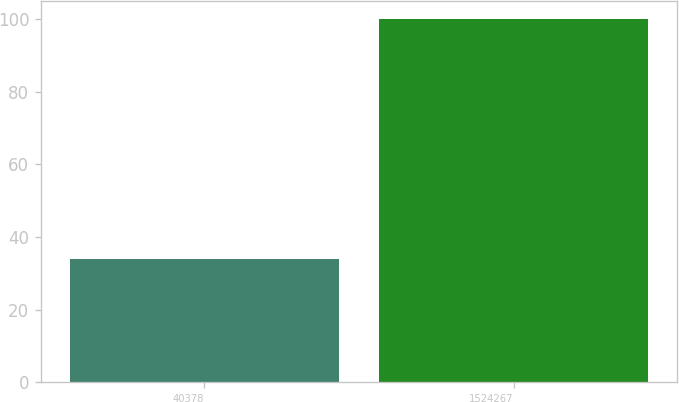Convert chart to OTSL. <chart><loc_0><loc_0><loc_500><loc_500><bar_chart><fcel>40378<fcel>1524267<nl><fcel>34<fcel>100<nl></chart> 